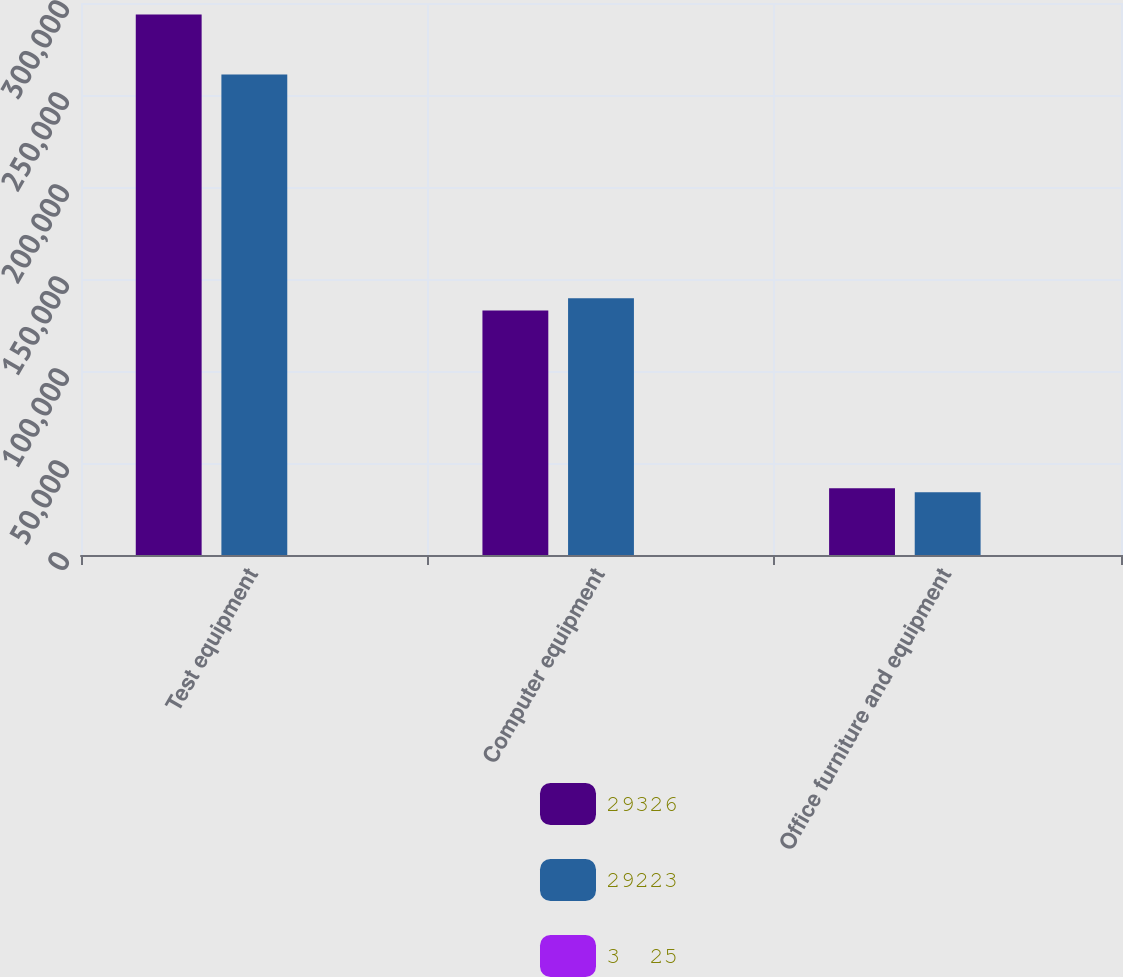<chart> <loc_0><loc_0><loc_500><loc_500><stacked_bar_chart><ecel><fcel>Test equipment<fcel>Computer equipment<fcel>Office furniture and equipment<nl><fcel>29326<fcel>293807<fcel>132896<fcel>36239<nl><fcel>29223<fcel>261172<fcel>139482<fcel>34091<nl><fcel>3  25<fcel>3<fcel>3<fcel>5<nl></chart> 